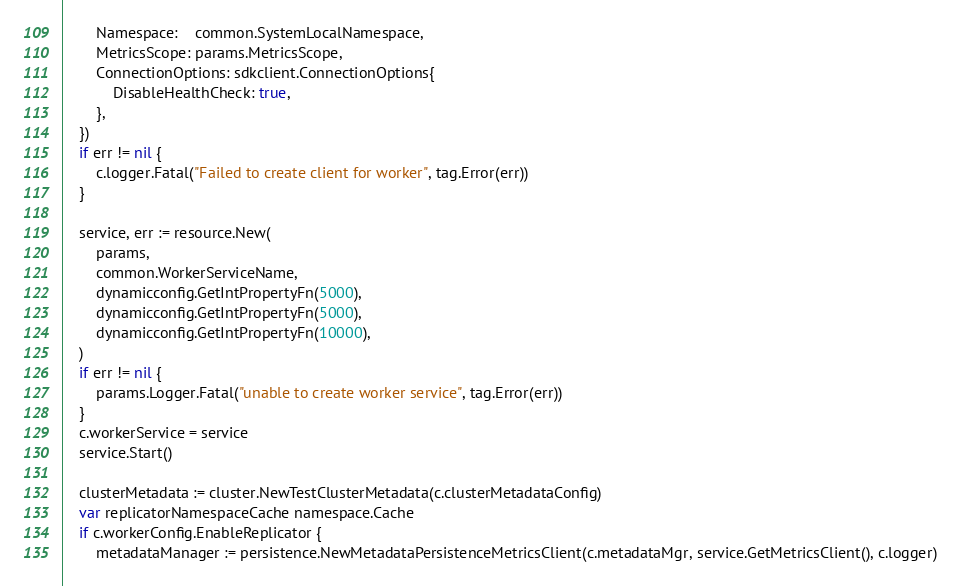<code> <loc_0><loc_0><loc_500><loc_500><_Go_>		Namespace:    common.SystemLocalNamespace,
		MetricsScope: params.MetricsScope,
		ConnectionOptions: sdkclient.ConnectionOptions{
			DisableHealthCheck: true,
		},
	})
	if err != nil {
		c.logger.Fatal("Failed to create client for worker", tag.Error(err))
	}

	service, err := resource.New(
		params,
		common.WorkerServiceName,
		dynamicconfig.GetIntPropertyFn(5000),
		dynamicconfig.GetIntPropertyFn(5000),
		dynamicconfig.GetIntPropertyFn(10000),
	)
	if err != nil {
		params.Logger.Fatal("unable to create worker service", tag.Error(err))
	}
	c.workerService = service
	service.Start()

	clusterMetadata := cluster.NewTestClusterMetadata(c.clusterMetadataConfig)
	var replicatorNamespaceCache namespace.Cache
	if c.workerConfig.EnableReplicator {
		metadataManager := persistence.NewMetadataPersistenceMetricsClient(c.metadataMgr, service.GetMetricsClient(), c.logger)</code> 